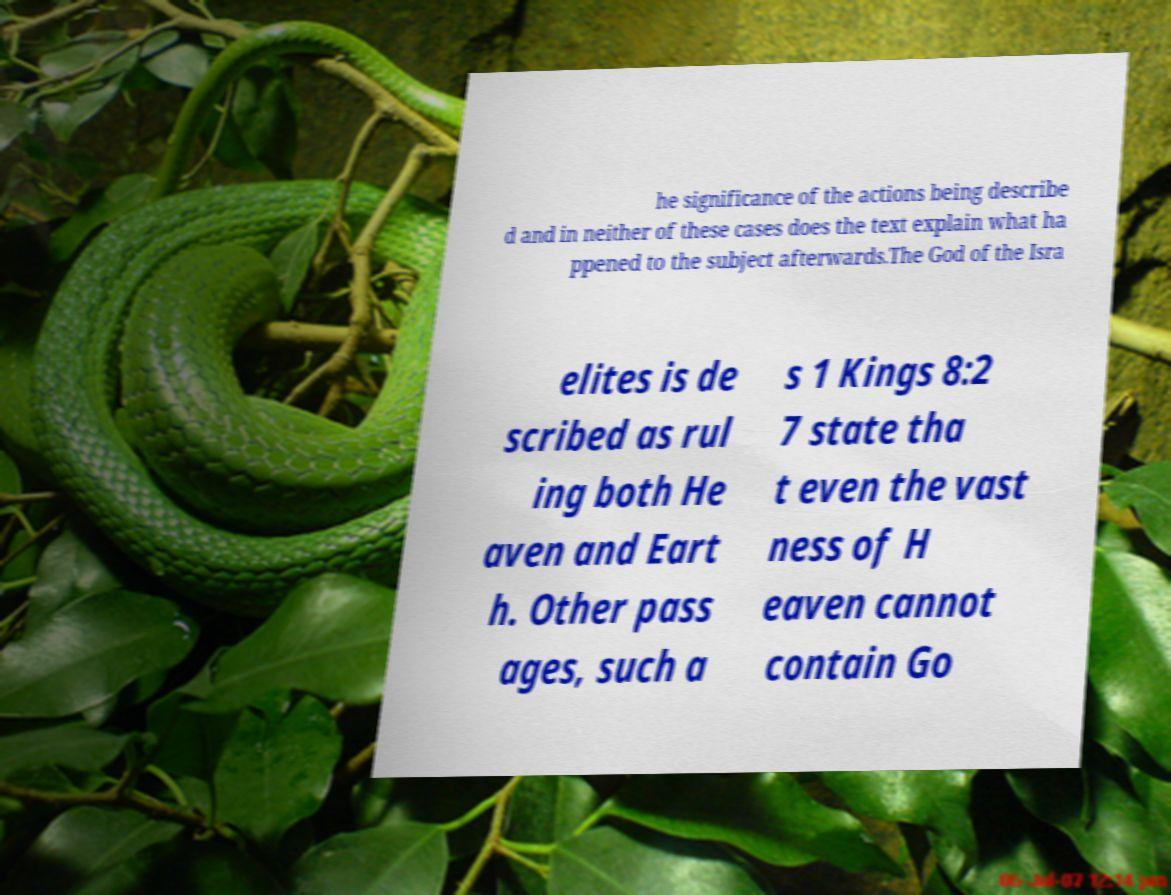Could you assist in decoding the text presented in this image and type it out clearly? he significance of the actions being describe d and in neither of these cases does the text explain what ha ppened to the subject afterwards.The God of the Isra elites is de scribed as rul ing both He aven and Eart h. Other pass ages, such a s 1 Kings 8:2 7 state tha t even the vast ness of H eaven cannot contain Go 